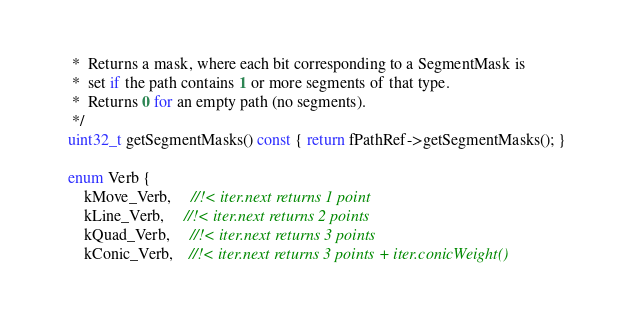<code> <loc_0><loc_0><loc_500><loc_500><_C_>     *  Returns a mask, where each bit corresponding to a SegmentMask is
     *  set if the path contains 1 or more segments of that type.
     *  Returns 0 for an empty path (no segments).
     */
    uint32_t getSegmentMasks() const { return fPathRef->getSegmentMasks(); }

    enum Verb {
        kMove_Verb,     //!< iter.next returns 1 point
        kLine_Verb,     //!< iter.next returns 2 points
        kQuad_Verb,     //!< iter.next returns 3 points
        kConic_Verb,    //!< iter.next returns 3 points + iter.conicWeight()</code> 